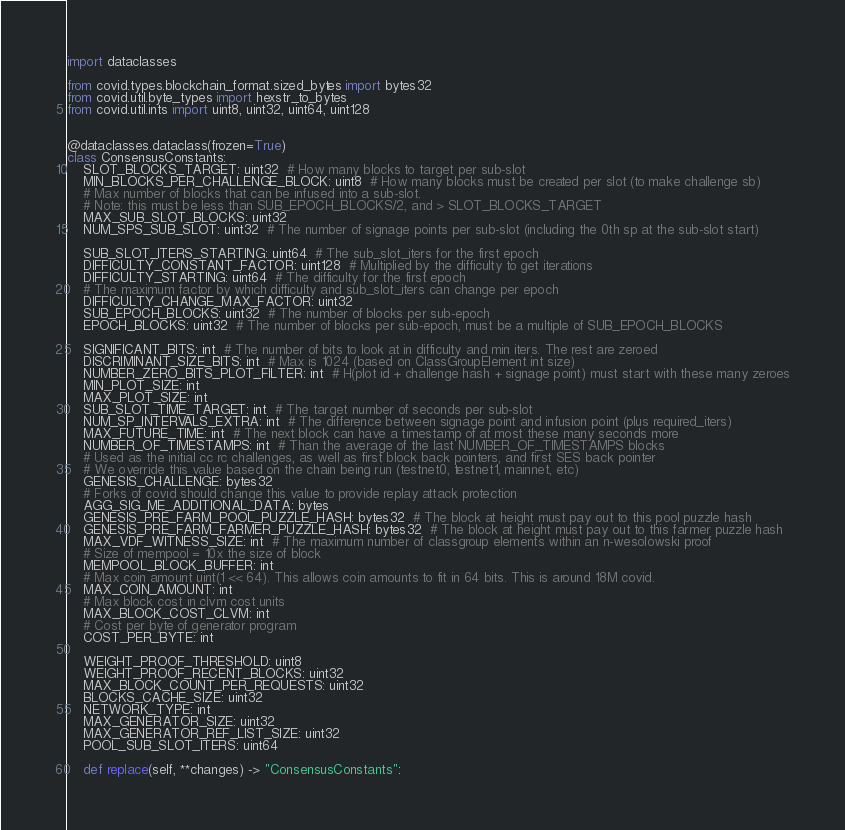<code> <loc_0><loc_0><loc_500><loc_500><_Python_>import dataclasses

from covid.types.blockchain_format.sized_bytes import bytes32
from covid.util.byte_types import hexstr_to_bytes
from covid.util.ints import uint8, uint32, uint64, uint128


@dataclasses.dataclass(frozen=True)
class ConsensusConstants:
    SLOT_BLOCKS_TARGET: uint32  # How many blocks to target per sub-slot
    MIN_BLOCKS_PER_CHALLENGE_BLOCK: uint8  # How many blocks must be created per slot (to make challenge sb)
    # Max number of blocks that can be infused into a sub-slot.
    # Note: this must be less than SUB_EPOCH_BLOCKS/2, and > SLOT_BLOCKS_TARGET
    MAX_SUB_SLOT_BLOCKS: uint32
    NUM_SPS_SUB_SLOT: uint32  # The number of signage points per sub-slot (including the 0th sp at the sub-slot start)

    SUB_SLOT_ITERS_STARTING: uint64  # The sub_slot_iters for the first epoch
    DIFFICULTY_CONSTANT_FACTOR: uint128  # Multiplied by the difficulty to get iterations
    DIFFICULTY_STARTING: uint64  # The difficulty for the first epoch
    # The maximum factor by which difficulty and sub_slot_iters can change per epoch
    DIFFICULTY_CHANGE_MAX_FACTOR: uint32
    SUB_EPOCH_BLOCKS: uint32  # The number of blocks per sub-epoch
    EPOCH_BLOCKS: uint32  # The number of blocks per sub-epoch, must be a multiple of SUB_EPOCH_BLOCKS

    SIGNIFICANT_BITS: int  # The number of bits to look at in difficulty and min iters. The rest are zeroed
    DISCRIMINANT_SIZE_BITS: int  # Max is 1024 (based on ClassGroupElement int size)
    NUMBER_ZERO_BITS_PLOT_FILTER: int  # H(plot id + challenge hash + signage point) must start with these many zeroes
    MIN_PLOT_SIZE: int
    MAX_PLOT_SIZE: int
    SUB_SLOT_TIME_TARGET: int  # The target number of seconds per sub-slot
    NUM_SP_INTERVALS_EXTRA: int  # The difference between signage point and infusion point (plus required_iters)
    MAX_FUTURE_TIME: int  # The next block can have a timestamp of at most these many seconds more
    NUMBER_OF_TIMESTAMPS: int  # Than the average of the last NUMBER_OF_TIMESTAMPS blocks
    # Used as the initial cc rc challenges, as well as first block back pointers, and first SES back pointer
    # We override this value based on the chain being run (testnet0, testnet1, mainnet, etc)
    GENESIS_CHALLENGE: bytes32
    # Forks of covid should change this value to provide replay attack protection
    AGG_SIG_ME_ADDITIONAL_DATA: bytes
    GENESIS_PRE_FARM_POOL_PUZZLE_HASH: bytes32  # The block at height must pay out to this pool puzzle hash
    GENESIS_PRE_FARM_FARMER_PUZZLE_HASH: bytes32  # The block at height must pay out to this farmer puzzle hash
    MAX_VDF_WITNESS_SIZE: int  # The maximum number of classgroup elements within an n-wesolowski proof
    # Size of mempool = 10x the size of block
    MEMPOOL_BLOCK_BUFFER: int
    # Max coin amount uint(1 << 64). This allows coin amounts to fit in 64 bits. This is around 18M covid.
    MAX_COIN_AMOUNT: int
    # Max block cost in clvm cost units
    MAX_BLOCK_COST_CLVM: int
    # Cost per byte of generator program
    COST_PER_BYTE: int

    WEIGHT_PROOF_THRESHOLD: uint8
    WEIGHT_PROOF_RECENT_BLOCKS: uint32
    MAX_BLOCK_COUNT_PER_REQUESTS: uint32
    BLOCKS_CACHE_SIZE: uint32
    NETWORK_TYPE: int
    MAX_GENERATOR_SIZE: uint32
    MAX_GENERATOR_REF_LIST_SIZE: uint32
    POOL_SUB_SLOT_ITERS: uint64

    def replace(self, **changes) -> "ConsensusConstants":</code> 